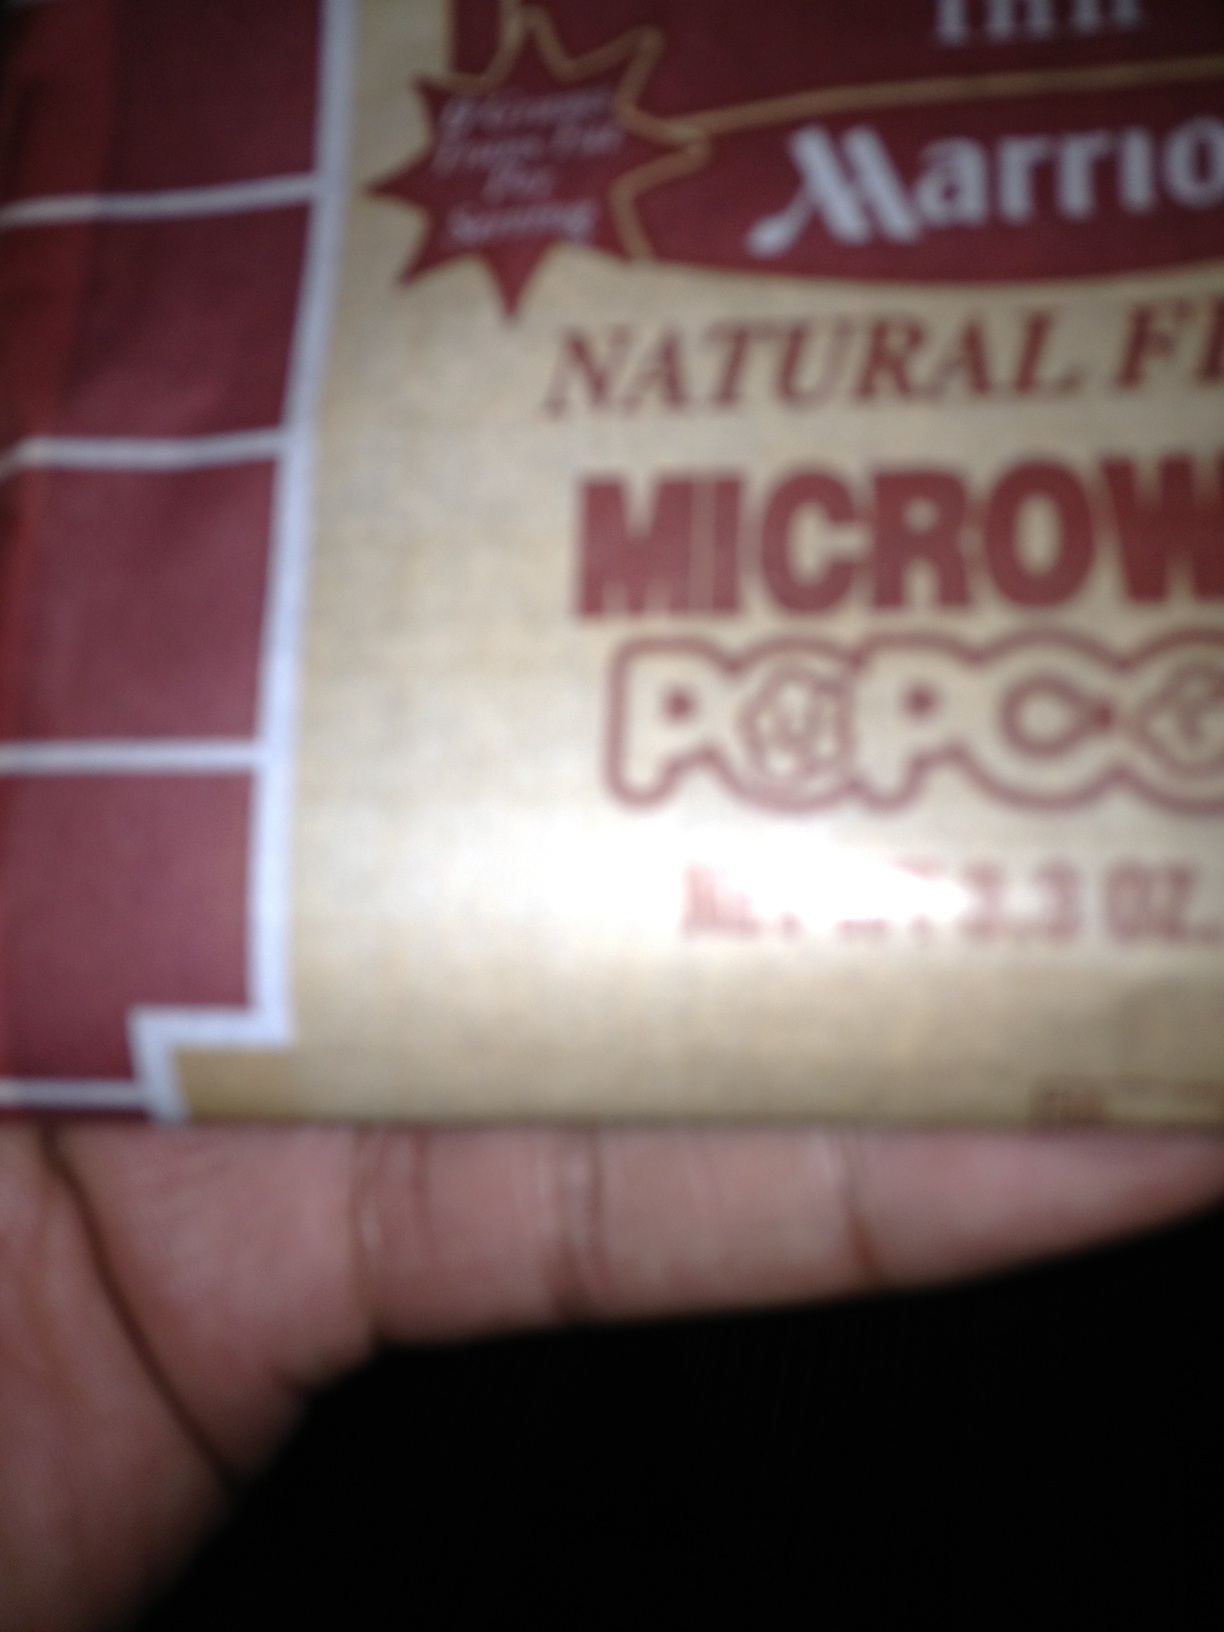Can you tell what ingredients are listed on this popcorn package? Unfortunately, the text on the package is blurry and unreadable from the image provided. For detailed ingredient information, it would be best to check directly on the package or the manufacturer's website. 